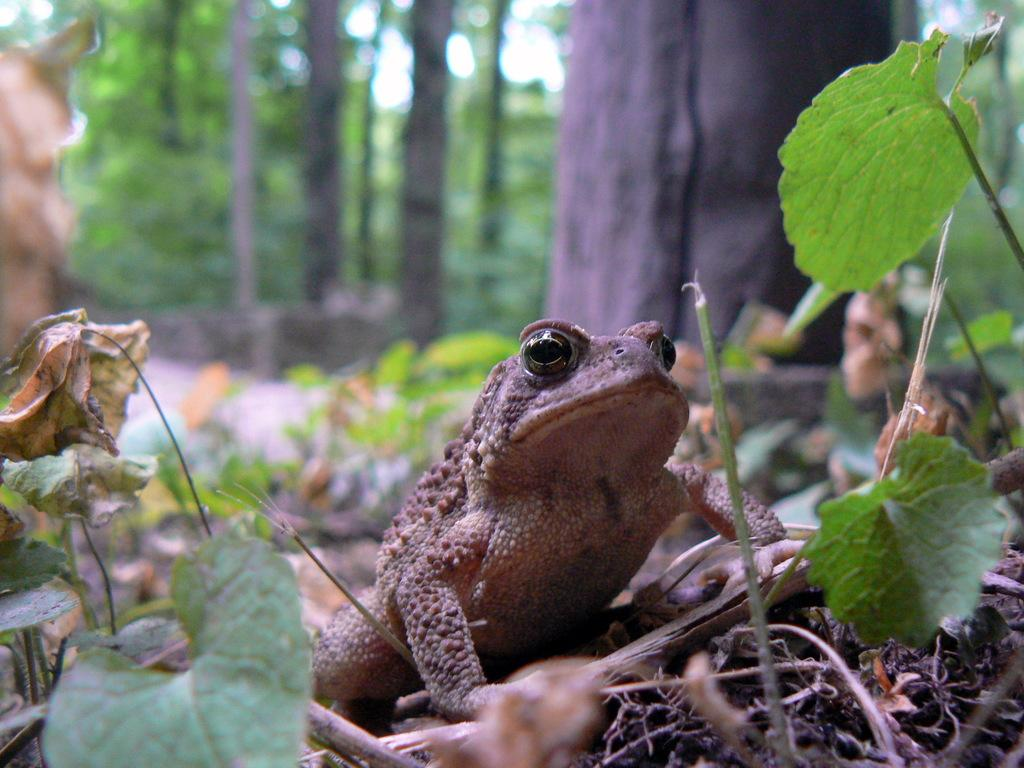What animal is on the ground in the image? There is a frog on the ground in the image. What can be seen in the background of the image? There are trees, plants, and the sky visible in the background of the image. What type of door can be seen in the image? There is no door present in the image; it features a frog on the ground and natural elements in the background. 